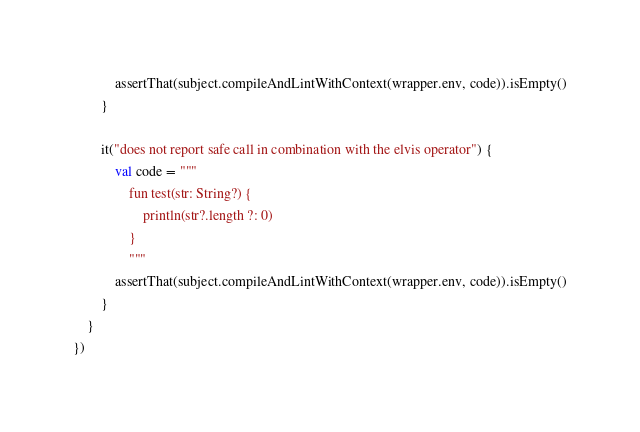Convert code to text. <code><loc_0><loc_0><loc_500><loc_500><_Kotlin_>            assertThat(subject.compileAndLintWithContext(wrapper.env, code)).isEmpty()
        }

        it("does not report safe call in combination with the elvis operator") {
            val code = """
                fun test(str: String?) {
                    println(str?.length ?: 0)
                }
                """
            assertThat(subject.compileAndLintWithContext(wrapper.env, code)).isEmpty()
        }
    }
})
</code> 